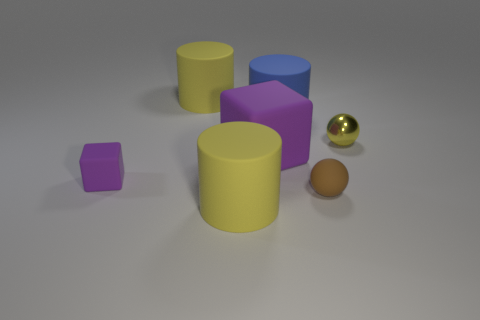Subtract all purple cubes. How many were subtracted if there are1purple cubes left? 1 Add 3 purple cylinders. How many objects exist? 10 Subtract all cubes. How many objects are left? 5 Add 6 rubber blocks. How many rubber blocks are left? 8 Add 2 small blocks. How many small blocks exist? 3 Subtract 0 red cubes. How many objects are left? 7 Subtract all yellow metal cylinders. Subtract all yellow matte cylinders. How many objects are left? 5 